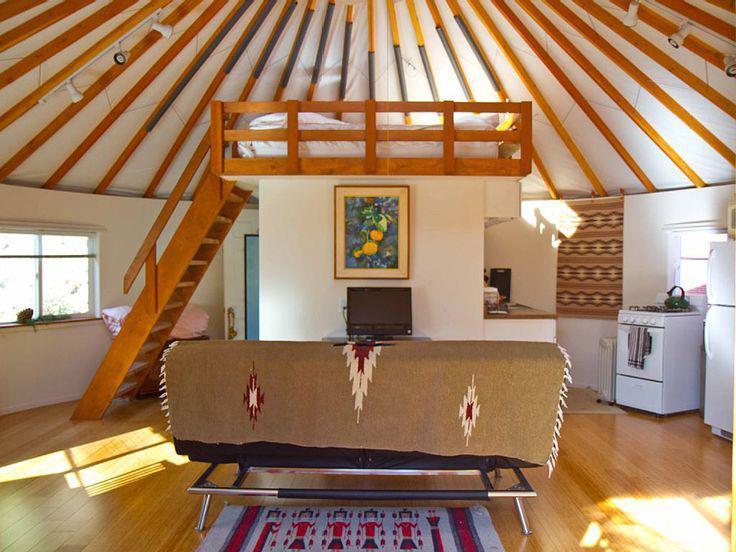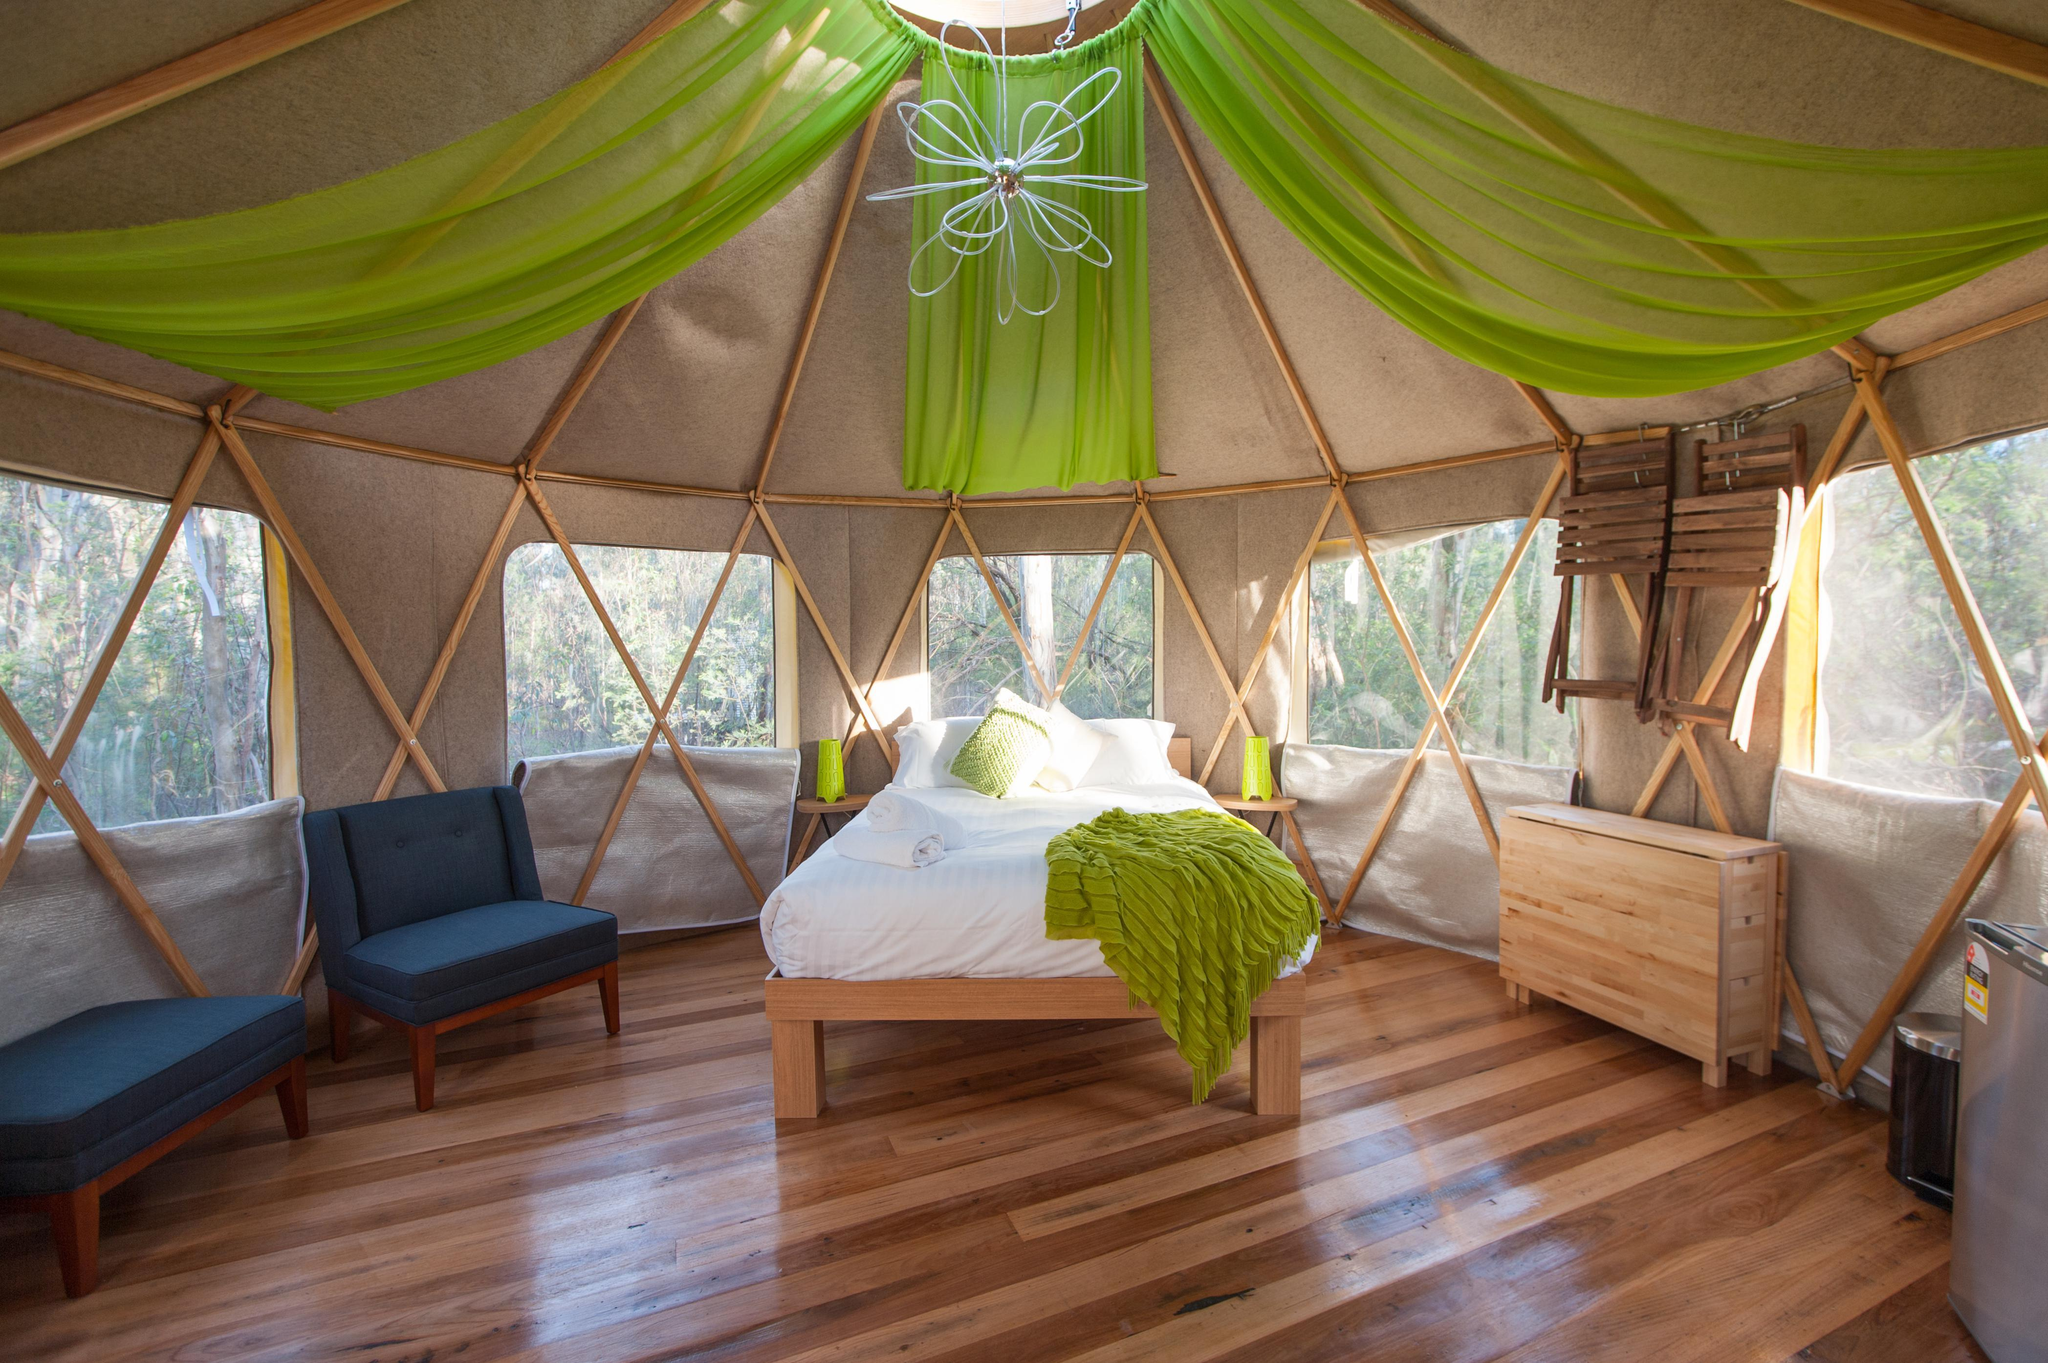The first image is the image on the left, the second image is the image on the right. Analyze the images presented: Is the assertion "There is one fram on the wall in the image on the left" valid? Answer yes or no. Yes. 